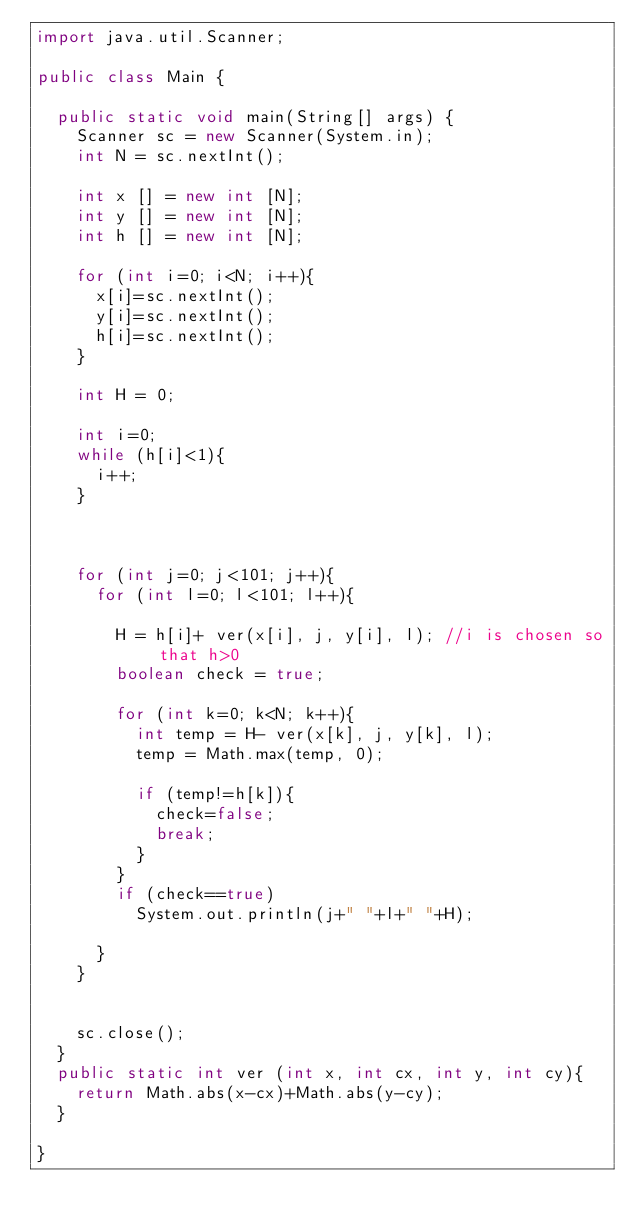<code> <loc_0><loc_0><loc_500><loc_500><_Java_>import java.util.Scanner;

public class Main {

	public static void main(String[] args) {
		Scanner sc = new Scanner(System.in);
		int N = sc.nextInt();
		
		int x [] = new int [N];
		int y [] = new int [N];
		int h [] = new int [N];
		
		for (int i=0; i<N; i++){
			x[i]=sc.nextInt();
			y[i]=sc.nextInt();
			h[i]=sc.nextInt();
		}
		
		int H = 0;
	
		int i=0;
		while (h[i]<1){
			i++;
		}
		
		
			
		for (int j=0; j<101; j++){
			for (int l=0; l<101; l++){
				
				H = h[i]+ ver(x[i], j, y[i], l); //i is chosen so that h>0
				boolean check = true;
				
				for (int k=0; k<N; k++){
					int temp = H- ver(x[k], j, y[k], l);
					temp = Math.max(temp, 0);
					
					if (temp!=h[k]){
						check=false;
						break;
					}
				}
				if (check==true)
					System.out.println(j+" "+l+" "+H);
				
			}
		}
		
		
		sc.close();
	}
	public static int ver (int x, int cx, int y, int cy){
		return Math.abs(x-cx)+Math.abs(y-cy);
	}

}</code> 